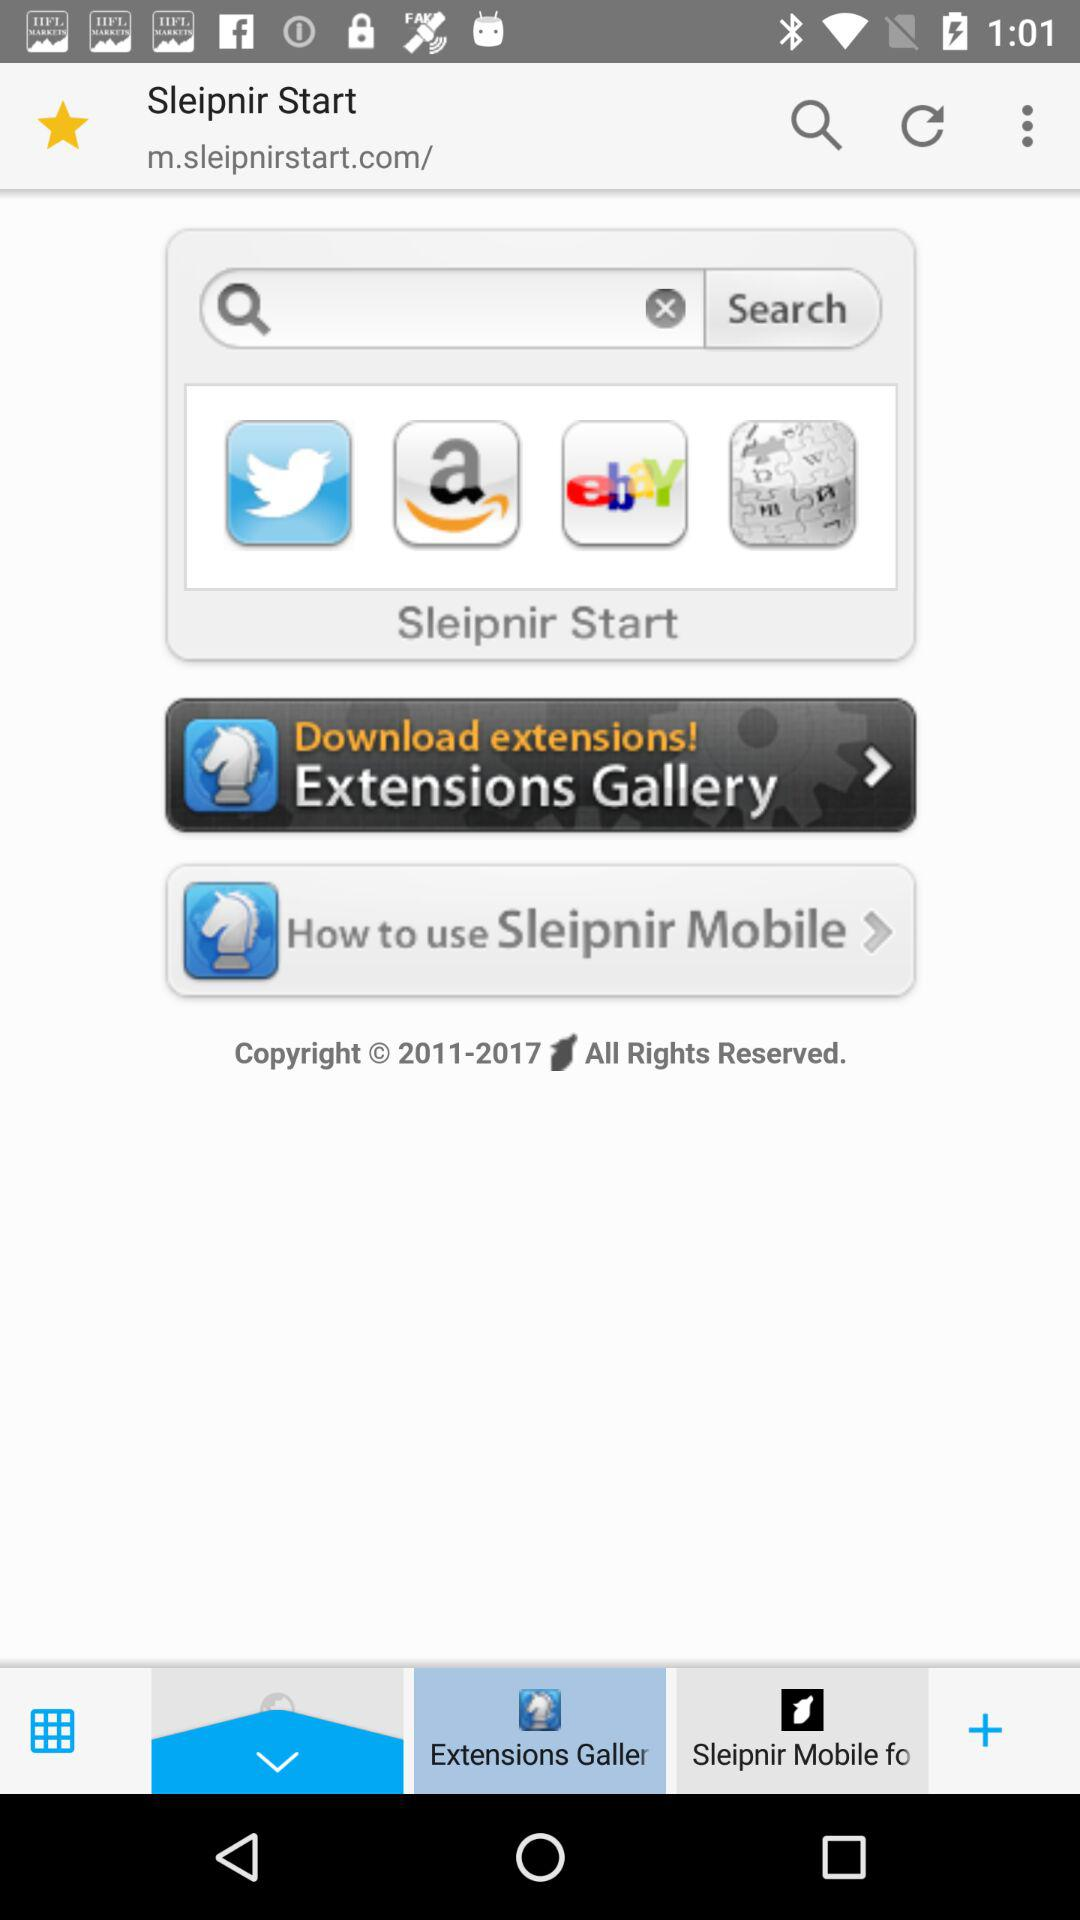What is the name of the application? The application name is Sleipnir Start. 